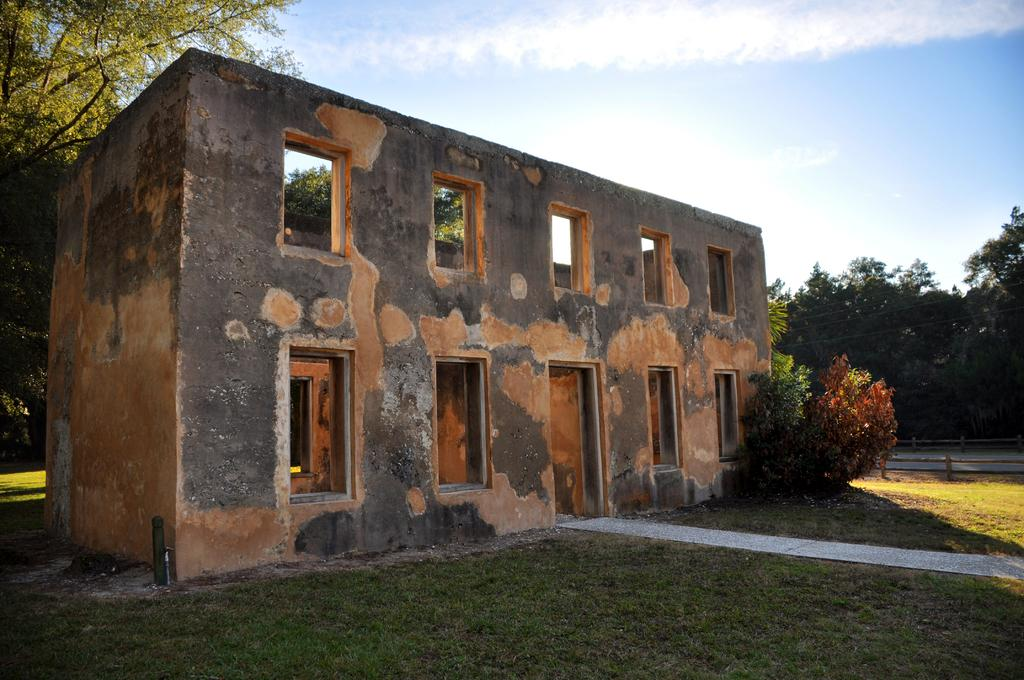What type of structure is visible in the image? There is an old construction in the image. What can be seen on the left side of the image? There are trees on the left side of the image. What is visible at the top of the image? The sky is visible at the top of the image. What type of vein is visible in the image? There is no vein present in the image. How does the old construction rest in the image? The old construction does not rest in the image; it is stationary and visible. 